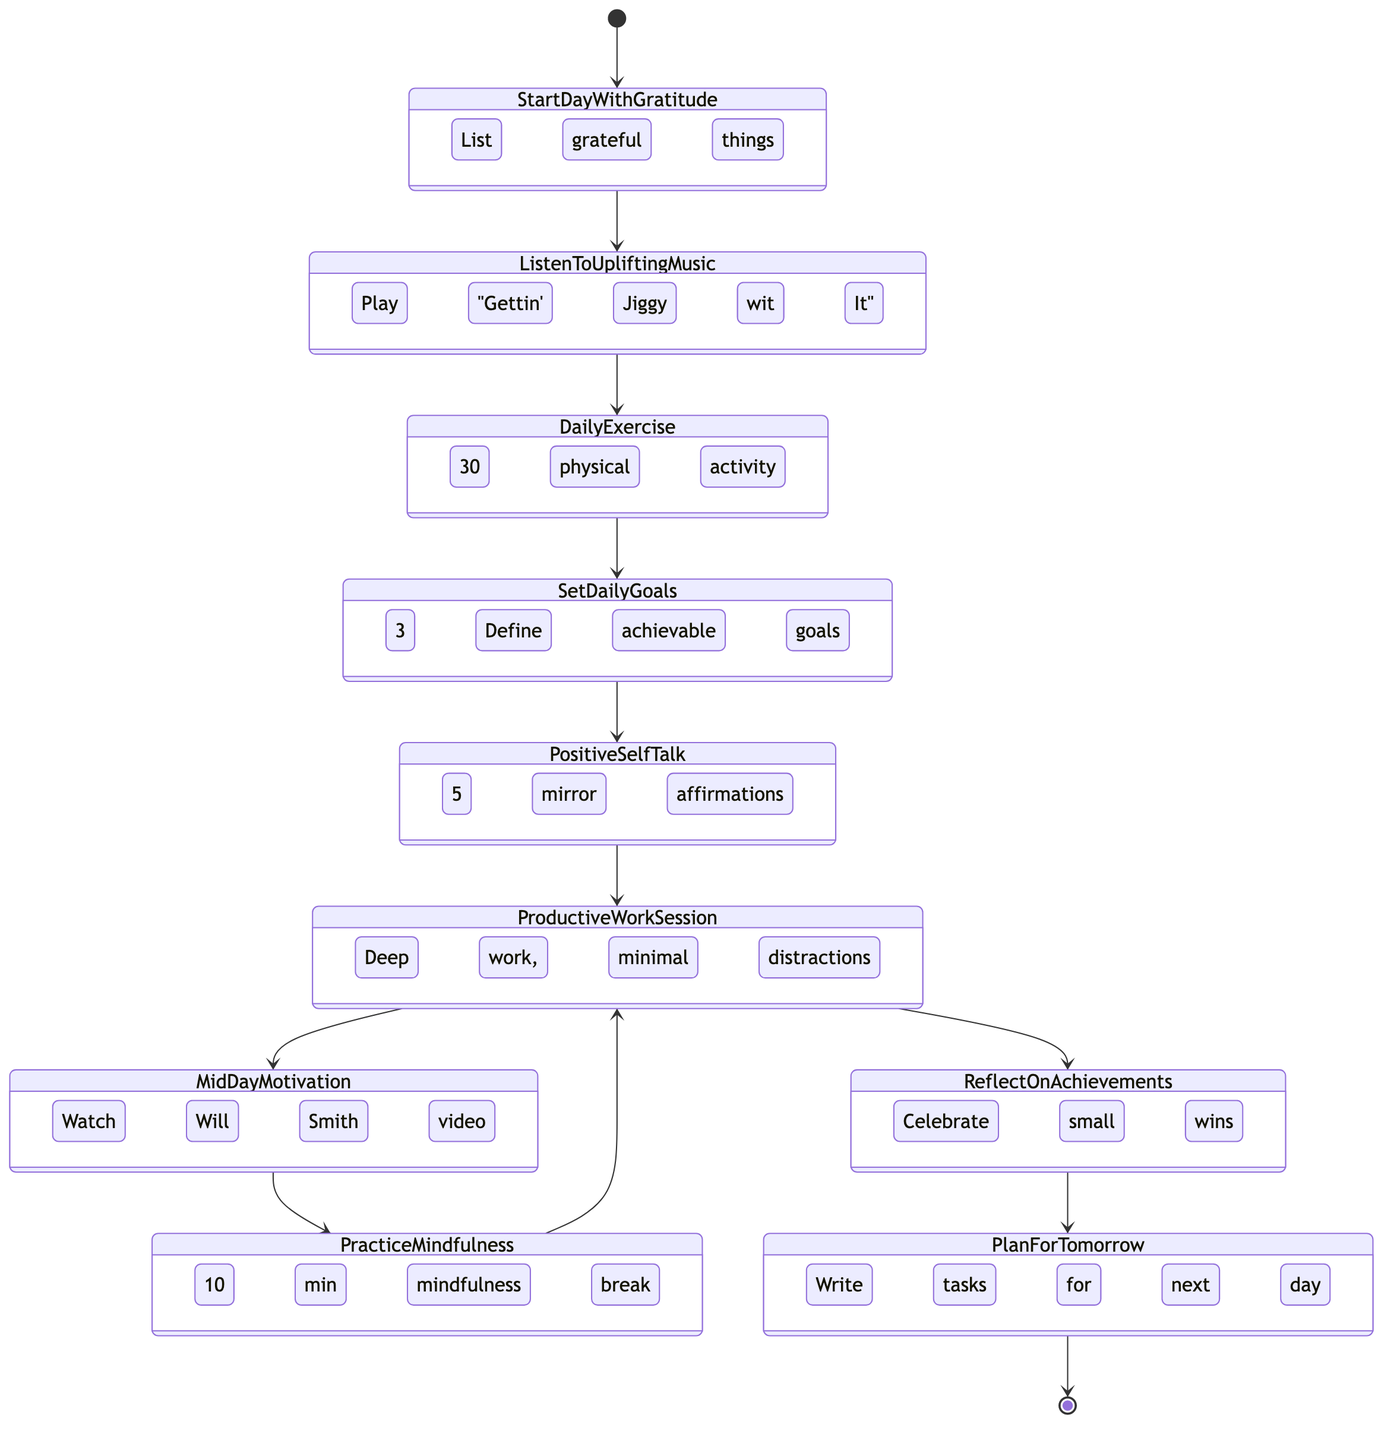What is the first activity in the routine? The first activity in the routine is the starting point represented in the diagram, which is "StartDayWithGratitude."
Answer: StartDayWithGratitude How many activities are in the diagram? By counting all the distinct activities listed in the diagram, we find that there are 10 activities in total.
Answer: 10 What comes after "PracticeMindfulness"? Following "PracticeMindfulness," the next activity as shown in the diagram is "ProductiveWorkSession."
Answer: ProductiveWorkSession Which activity includes watching a video? The activity that involves watching a video is "MidDayMotivation," where you watch a short, inspiring Will Smith motivational video.
Answer: MidDayMotivation How many times is "ProductiveWorkSession" represented in the diagram? "ProductiveWorkSession" appears three times in the diagram due to the flow returning to it after practicing mindfulness and after reflecting on achievements.
Answer: 3 Which activity involves physical exercise? The activity that involves physical exercise is named "DailyExercise," which specifies engaging in at least 30 minutes of it.
Answer: DailyExercise What is the last activity before the day ends? The last activity before concluding the day is "PlanForTomorrow," where one writes down tasks and goals for the next day.
Answer: PlanForTomorrow What activity is related to setting personal goals? The activity associated with setting personal goals is "SetDailyGoals," which states to define three achievable goals for the day.
Answer: SetDailyGoals What type of affirmation is done in "PositiveSelfTalk"? The affirmation done in "PositiveSelfTalk" consists of looking in the mirror and encouraging yourself with positive affirmations.
Answer: Positive affirmations 